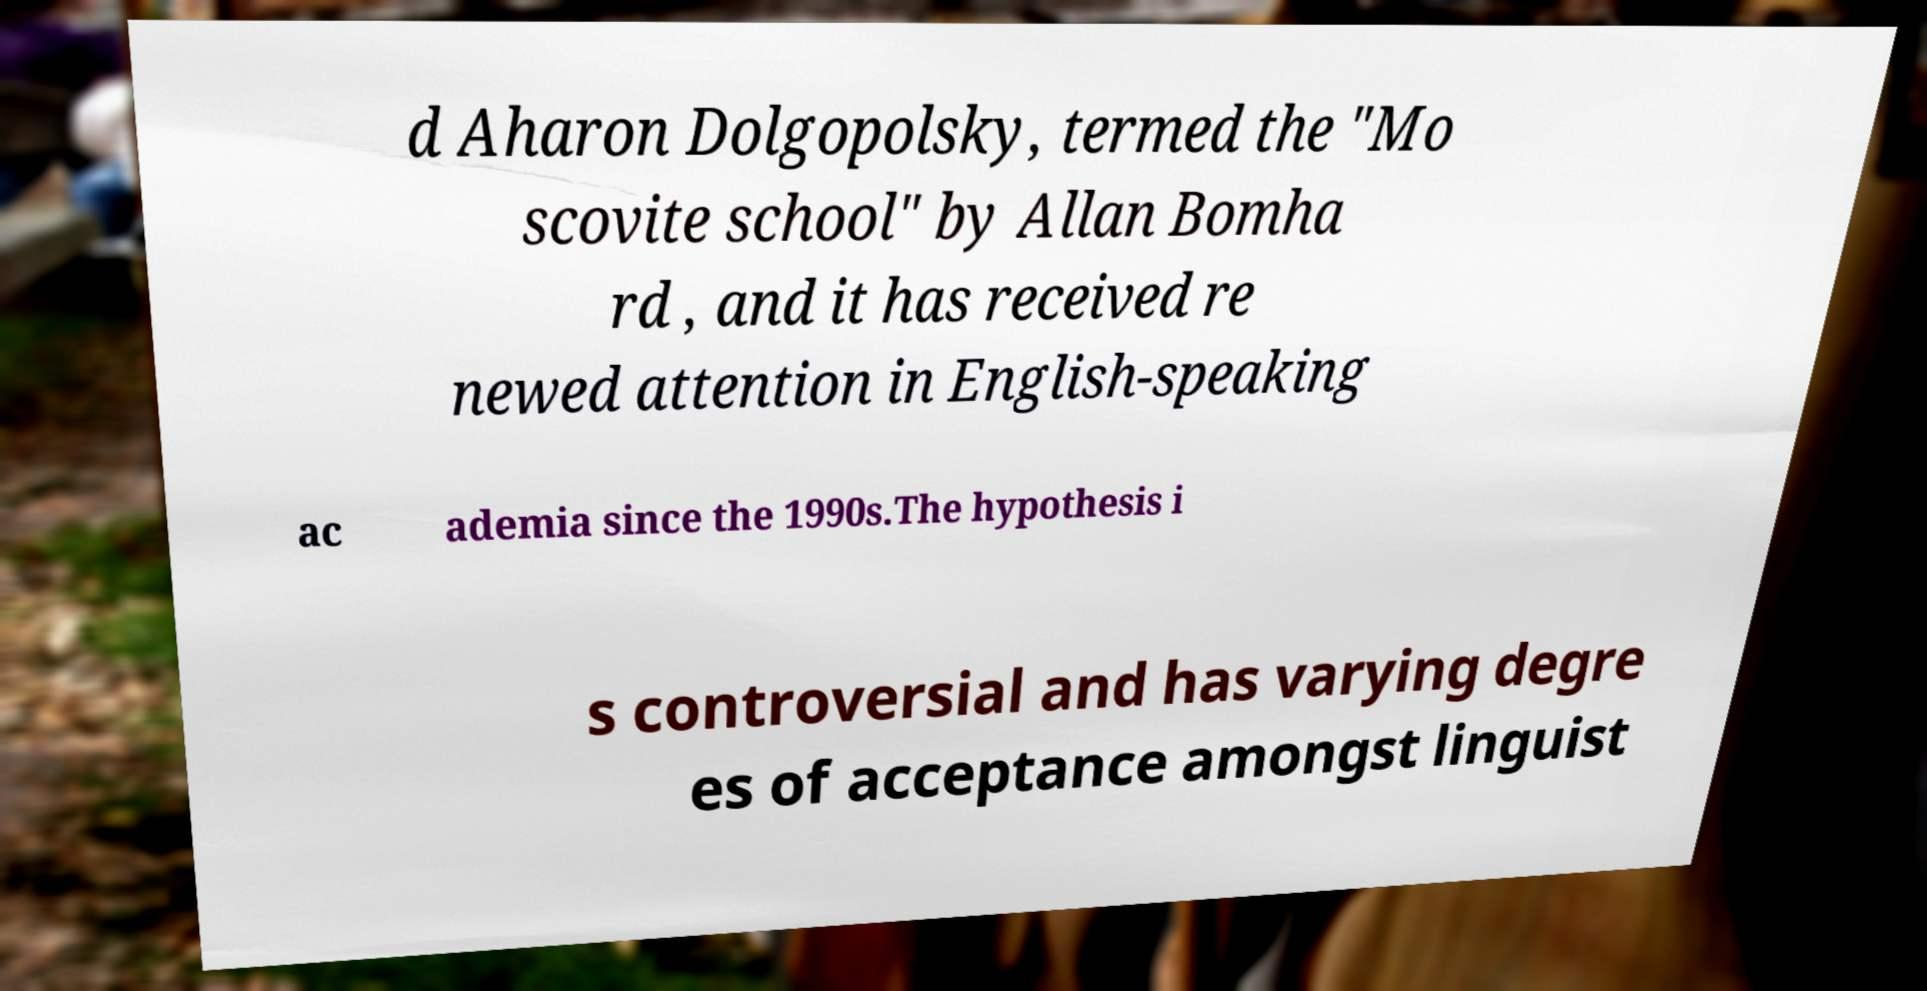Can you accurately transcribe the text from the provided image for me? d Aharon Dolgopolsky, termed the "Mo scovite school" by Allan Bomha rd , and it has received re newed attention in English-speaking ac ademia since the 1990s.The hypothesis i s controversial and has varying degre es of acceptance amongst linguist 